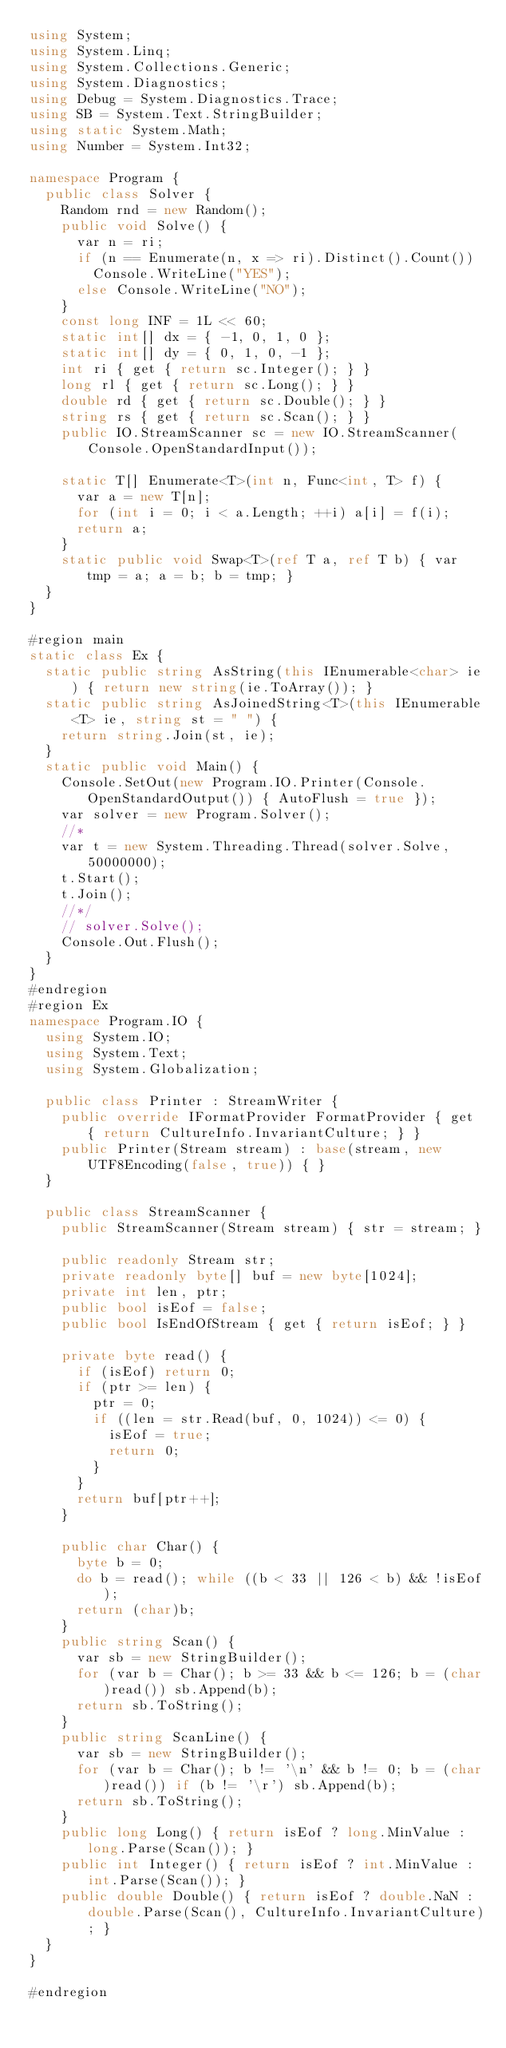<code> <loc_0><loc_0><loc_500><loc_500><_C#_>using System;
using System.Linq;
using System.Collections.Generic;
using System.Diagnostics;
using Debug = System.Diagnostics.Trace;
using SB = System.Text.StringBuilder;
using static System.Math;
using Number = System.Int32;

namespace Program {
	public class Solver {
		Random rnd = new Random();
		public void Solve() {
			var n = ri;
			if (n == Enumerate(n, x => ri).Distinct().Count())
				Console.WriteLine("YES");
			else Console.WriteLine("NO");
		}
		const long INF = 1L << 60;
		static int[] dx = { -1, 0, 1, 0 };
		static int[] dy = { 0, 1, 0, -1 };
		int ri { get { return sc.Integer(); } }
		long rl { get { return sc.Long(); } }
		double rd { get { return sc.Double(); } }
		string rs { get { return sc.Scan(); } }
		public IO.StreamScanner sc = new IO.StreamScanner(Console.OpenStandardInput());

		static T[] Enumerate<T>(int n, Func<int, T> f) {
			var a = new T[n];
			for (int i = 0; i < a.Length; ++i) a[i] = f(i);
			return a;
		}
		static public void Swap<T>(ref T a, ref T b) { var tmp = a; a = b; b = tmp; }
	}
}

#region main
static class Ex {
	static public string AsString(this IEnumerable<char> ie) { return new string(ie.ToArray()); }
	static public string AsJoinedString<T>(this IEnumerable<T> ie, string st = " ") {
		return string.Join(st, ie);
	}
	static public void Main() {
		Console.SetOut(new Program.IO.Printer(Console.OpenStandardOutput()) { AutoFlush = true });
		var solver = new Program.Solver();
		//* 
		var t = new System.Threading.Thread(solver.Solve, 50000000);
		t.Start();
		t.Join();
		//*/
		// solver.Solve();
		Console.Out.Flush();
	}
}
#endregion
#region Ex
namespace Program.IO {
	using System.IO;
	using System.Text;
	using System.Globalization;

	public class Printer : StreamWriter {
		public override IFormatProvider FormatProvider { get { return CultureInfo.InvariantCulture; } }
		public Printer(Stream stream) : base(stream, new UTF8Encoding(false, true)) { }
	}

	public class StreamScanner {
		public StreamScanner(Stream stream) { str = stream; }

		public readonly Stream str;
		private readonly byte[] buf = new byte[1024];
		private int len, ptr;
		public bool isEof = false;
		public bool IsEndOfStream { get { return isEof; } }

		private byte read() {
			if (isEof) return 0;
			if (ptr >= len) {
				ptr = 0;
				if ((len = str.Read(buf, 0, 1024)) <= 0) {
					isEof = true;
					return 0;
				}
			}
			return buf[ptr++];
		}

		public char Char() {
			byte b = 0;
			do b = read(); while ((b < 33 || 126 < b) && !isEof);
			return (char)b;
		}
		public string Scan() {
			var sb = new StringBuilder();
			for (var b = Char(); b >= 33 && b <= 126; b = (char)read()) sb.Append(b);
			return sb.ToString();
		}
		public string ScanLine() {
			var sb = new StringBuilder();
			for (var b = Char(); b != '\n' && b != 0; b = (char)read()) if (b != '\r') sb.Append(b);
			return sb.ToString();
		}
		public long Long() { return isEof ? long.MinValue : long.Parse(Scan()); }
		public int Integer() { return isEof ? int.MinValue : int.Parse(Scan()); }
		public double Double() { return isEof ? double.NaN : double.Parse(Scan(), CultureInfo.InvariantCulture); }
	}
}

#endregion
</code> 